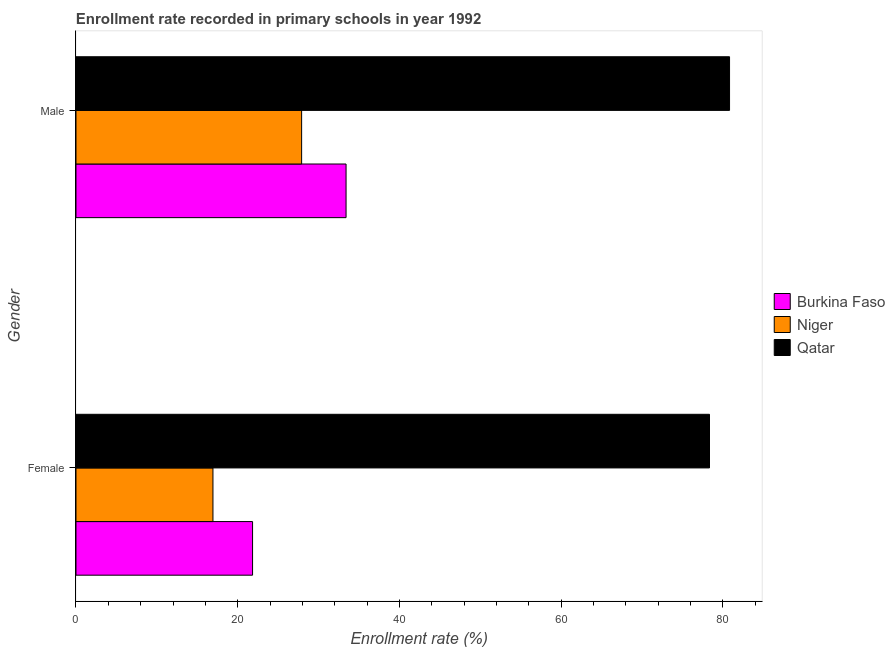How many different coloured bars are there?
Your answer should be compact. 3. Are the number of bars on each tick of the Y-axis equal?
Provide a short and direct response. Yes. What is the enrollment rate of male students in Burkina Faso?
Offer a very short reply. 33.4. Across all countries, what is the maximum enrollment rate of male students?
Ensure brevity in your answer.  80.81. Across all countries, what is the minimum enrollment rate of female students?
Provide a short and direct response. 16.94. In which country was the enrollment rate of male students maximum?
Make the answer very short. Qatar. In which country was the enrollment rate of female students minimum?
Offer a very short reply. Niger. What is the total enrollment rate of male students in the graph?
Keep it short and to the point. 142.11. What is the difference between the enrollment rate of female students in Qatar and that in Niger?
Provide a short and direct response. 61.4. What is the difference between the enrollment rate of male students in Niger and the enrollment rate of female students in Burkina Faso?
Provide a succinct answer. 6.07. What is the average enrollment rate of male students per country?
Offer a very short reply. 47.37. What is the difference between the enrollment rate of female students and enrollment rate of male students in Qatar?
Provide a short and direct response. -2.48. What is the ratio of the enrollment rate of female students in Qatar to that in Niger?
Give a very brief answer. 4.63. Is the enrollment rate of male students in Qatar less than that in Niger?
Give a very brief answer. No. What does the 2nd bar from the top in Female represents?
Provide a short and direct response. Niger. What does the 3rd bar from the bottom in Female represents?
Your answer should be very brief. Qatar. Are all the bars in the graph horizontal?
Your answer should be very brief. Yes. How many countries are there in the graph?
Your response must be concise. 3. What is the difference between two consecutive major ticks on the X-axis?
Provide a succinct answer. 20. Are the values on the major ticks of X-axis written in scientific E-notation?
Your response must be concise. No. Does the graph contain any zero values?
Make the answer very short. No. Where does the legend appear in the graph?
Make the answer very short. Center right. How many legend labels are there?
Provide a short and direct response. 3. How are the legend labels stacked?
Provide a succinct answer. Vertical. What is the title of the graph?
Provide a succinct answer. Enrollment rate recorded in primary schools in year 1992. Does "Brunei Darussalam" appear as one of the legend labels in the graph?
Make the answer very short. No. What is the label or title of the X-axis?
Ensure brevity in your answer.  Enrollment rate (%). What is the label or title of the Y-axis?
Keep it short and to the point. Gender. What is the Enrollment rate (%) of Burkina Faso in Female?
Offer a very short reply. 21.83. What is the Enrollment rate (%) of Niger in Female?
Ensure brevity in your answer.  16.94. What is the Enrollment rate (%) in Qatar in Female?
Provide a succinct answer. 78.34. What is the Enrollment rate (%) of Burkina Faso in Male?
Your response must be concise. 33.4. What is the Enrollment rate (%) in Niger in Male?
Your answer should be compact. 27.9. What is the Enrollment rate (%) in Qatar in Male?
Offer a terse response. 80.81. Across all Gender, what is the maximum Enrollment rate (%) in Burkina Faso?
Your response must be concise. 33.4. Across all Gender, what is the maximum Enrollment rate (%) of Niger?
Keep it short and to the point. 27.9. Across all Gender, what is the maximum Enrollment rate (%) of Qatar?
Provide a short and direct response. 80.81. Across all Gender, what is the minimum Enrollment rate (%) of Burkina Faso?
Ensure brevity in your answer.  21.83. Across all Gender, what is the minimum Enrollment rate (%) in Niger?
Make the answer very short. 16.94. Across all Gender, what is the minimum Enrollment rate (%) of Qatar?
Make the answer very short. 78.34. What is the total Enrollment rate (%) of Burkina Faso in the graph?
Offer a very short reply. 55.23. What is the total Enrollment rate (%) in Niger in the graph?
Give a very brief answer. 44.84. What is the total Enrollment rate (%) of Qatar in the graph?
Ensure brevity in your answer.  159.15. What is the difference between the Enrollment rate (%) in Burkina Faso in Female and that in Male?
Your answer should be very brief. -11.56. What is the difference between the Enrollment rate (%) of Niger in Female and that in Male?
Your answer should be compact. -10.96. What is the difference between the Enrollment rate (%) in Qatar in Female and that in Male?
Provide a succinct answer. -2.48. What is the difference between the Enrollment rate (%) in Burkina Faso in Female and the Enrollment rate (%) in Niger in Male?
Offer a terse response. -6.07. What is the difference between the Enrollment rate (%) in Burkina Faso in Female and the Enrollment rate (%) in Qatar in Male?
Your response must be concise. -58.98. What is the difference between the Enrollment rate (%) of Niger in Female and the Enrollment rate (%) of Qatar in Male?
Provide a short and direct response. -63.88. What is the average Enrollment rate (%) of Burkina Faso per Gender?
Your response must be concise. 27.62. What is the average Enrollment rate (%) of Niger per Gender?
Your answer should be compact. 22.42. What is the average Enrollment rate (%) of Qatar per Gender?
Your answer should be very brief. 79.58. What is the difference between the Enrollment rate (%) of Burkina Faso and Enrollment rate (%) of Niger in Female?
Make the answer very short. 4.9. What is the difference between the Enrollment rate (%) in Burkina Faso and Enrollment rate (%) in Qatar in Female?
Make the answer very short. -56.5. What is the difference between the Enrollment rate (%) of Niger and Enrollment rate (%) of Qatar in Female?
Offer a very short reply. -61.4. What is the difference between the Enrollment rate (%) of Burkina Faso and Enrollment rate (%) of Niger in Male?
Your answer should be very brief. 5.5. What is the difference between the Enrollment rate (%) of Burkina Faso and Enrollment rate (%) of Qatar in Male?
Offer a terse response. -47.42. What is the difference between the Enrollment rate (%) of Niger and Enrollment rate (%) of Qatar in Male?
Give a very brief answer. -52.92. What is the ratio of the Enrollment rate (%) of Burkina Faso in Female to that in Male?
Ensure brevity in your answer.  0.65. What is the ratio of the Enrollment rate (%) of Niger in Female to that in Male?
Your answer should be very brief. 0.61. What is the ratio of the Enrollment rate (%) in Qatar in Female to that in Male?
Provide a short and direct response. 0.97. What is the difference between the highest and the second highest Enrollment rate (%) of Burkina Faso?
Your answer should be compact. 11.56. What is the difference between the highest and the second highest Enrollment rate (%) of Niger?
Give a very brief answer. 10.96. What is the difference between the highest and the second highest Enrollment rate (%) of Qatar?
Offer a terse response. 2.48. What is the difference between the highest and the lowest Enrollment rate (%) of Burkina Faso?
Your answer should be very brief. 11.56. What is the difference between the highest and the lowest Enrollment rate (%) in Niger?
Make the answer very short. 10.96. What is the difference between the highest and the lowest Enrollment rate (%) of Qatar?
Your answer should be very brief. 2.48. 